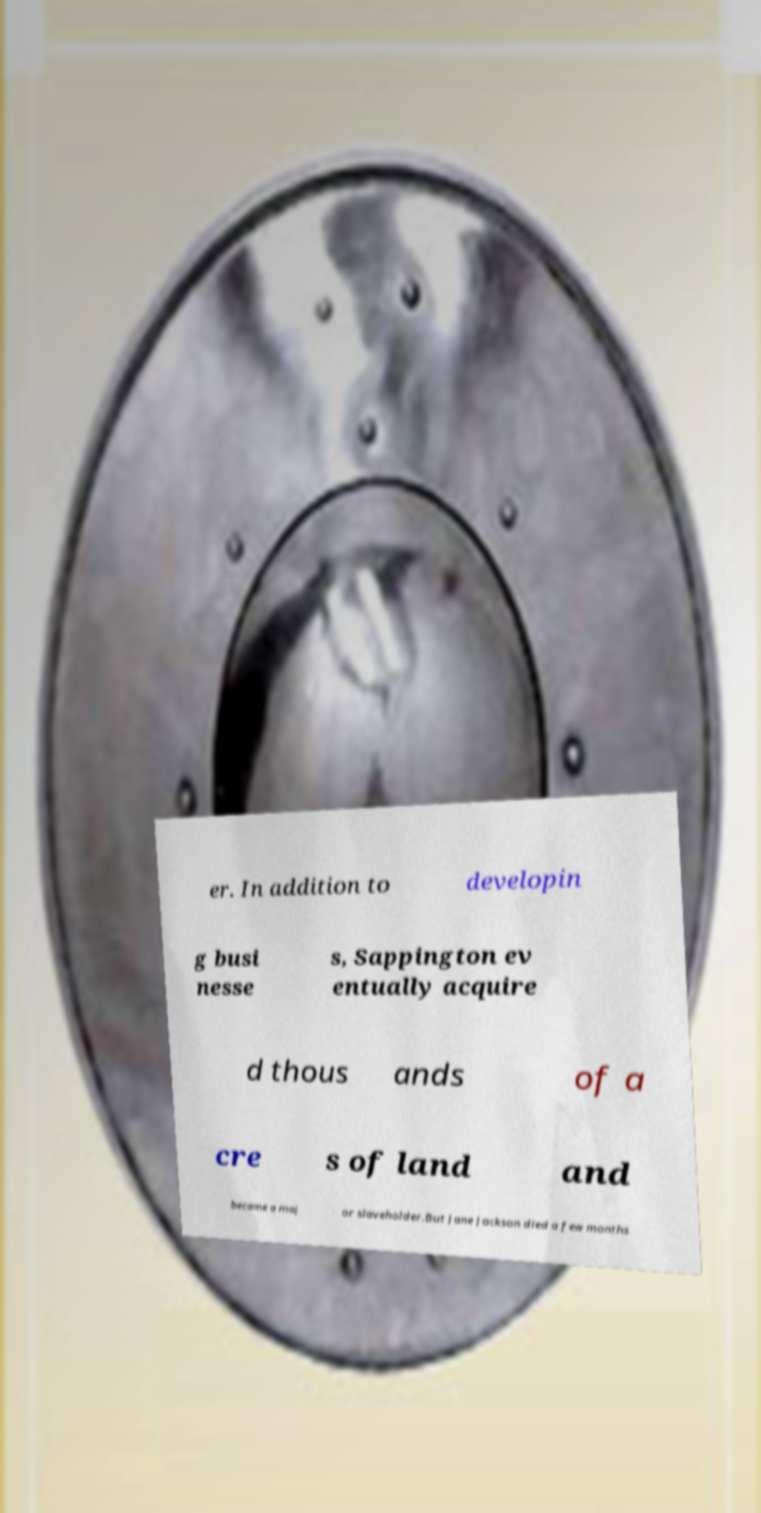Can you accurately transcribe the text from the provided image for me? er. In addition to developin g busi nesse s, Sappington ev entually acquire d thous ands of a cre s of land and became a maj or slaveholder.But Jane Jackson died a few months 